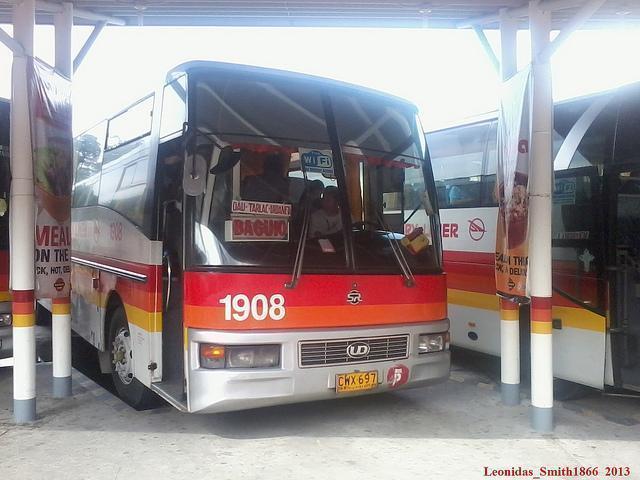What service is available when riding this bus?
Select the accurate answer and provide justification: `Answer: choice
Rationale: srationale.`
Options: Free lunch, wifi, hand towels, heated seats. Answer: wifi.
Rationale: They have wifi available. 